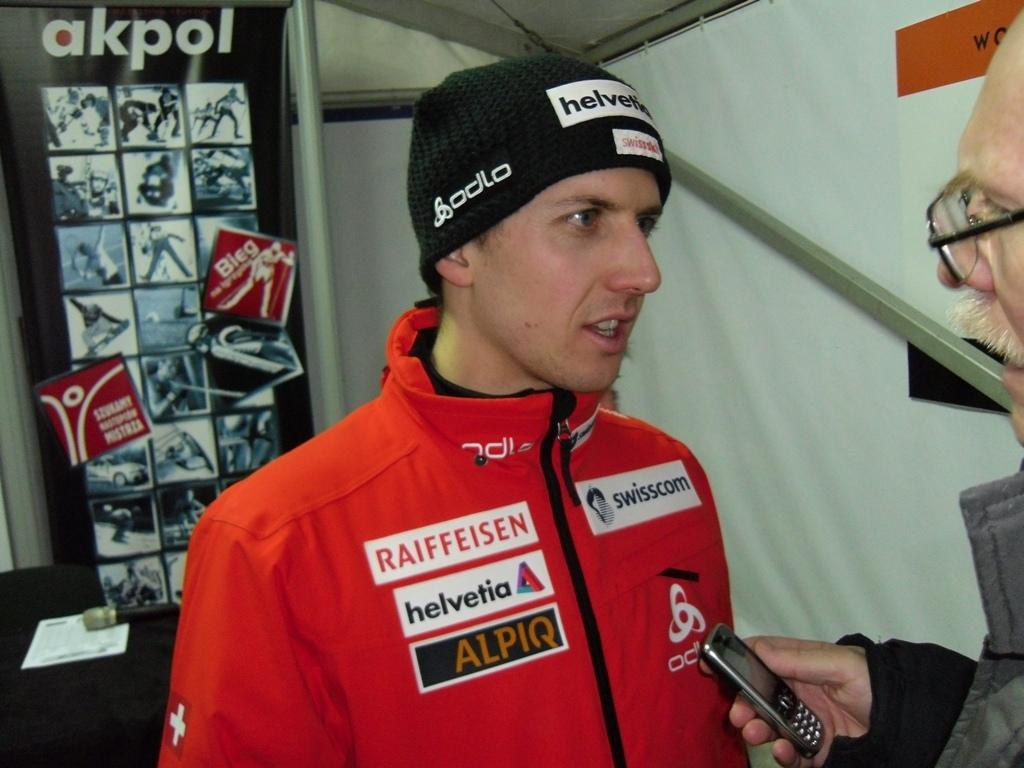Provide a one-sentence caption for the provided image. The winter athlete is sponsored by Raiffeisen, Helvetica, and Alpiq. 